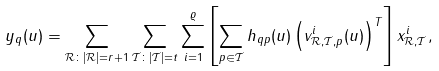Convert formula to latex. <formula><loc_0><loc_0><loc_500><loc_500>y _ { q } ( u ) & = \sum _ { \mathcal { R } \colon | \mathcal { R } | = r + 1 } \sum _ { \mathcal { T } \colon | \mathcal { T } | = t } \sum _ { i = 1 } ^ { \varrho } \left [ \sum _ { p \in \mathcal { T } } h _ { q p } ( u ) \left ( v _ { { \mathcal { R } } , { \mathcal { T } } , p } ^ { i } ( u ) \right ) ^ { T } \right ] x _ { { \mathcal { R } } , { \mathcal { T } } } ^ { i } ,</formula> 